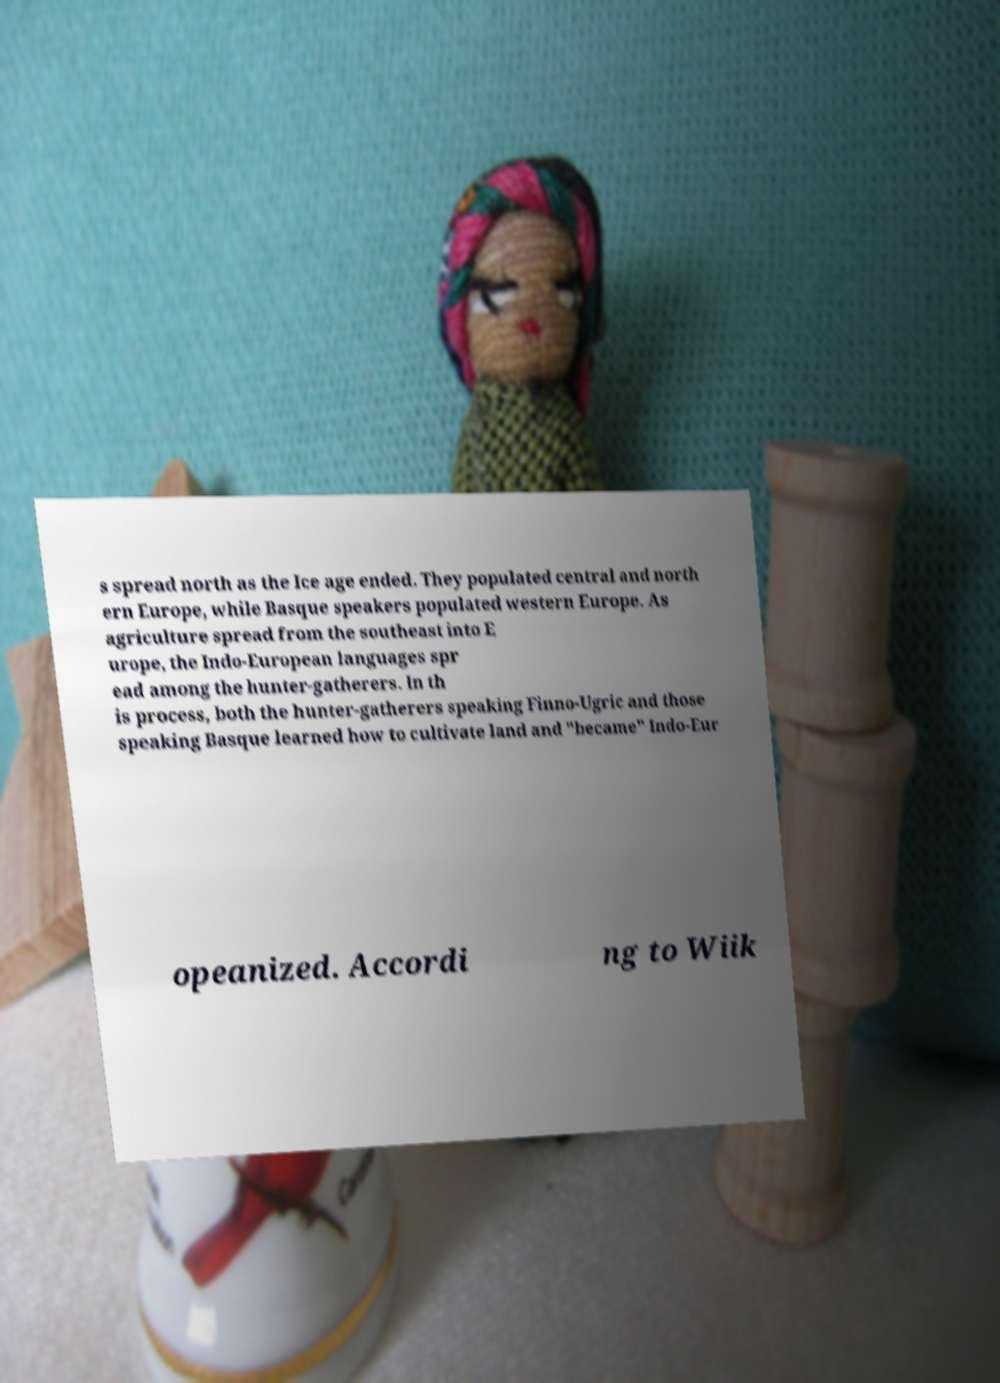Can you accurately transcribe the text from the provided image for me? s spread north as the Ice age ended. They populated central and north ern Europe, while Basque speakers populated western Europe. As agriculture spread from the southeast into E urope, the Indo-European languages spr ead among the hunter-gatherers. In th is process, both the hunter-gatherers speaking Finno-Ugric and those speaking Basque learned how to cultivate land and "became" Indo-Eur opeanized. Accordi ng to Wiik 